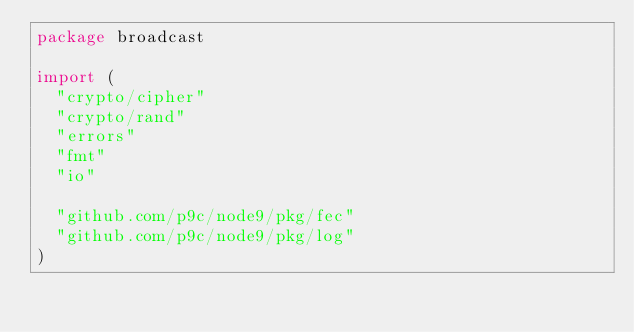<code> <loc_0><loc_0><loc_500><loc_500><_Go_>package broadcast

import (
	"crypto/cipher"
	"crypto/rand"
	"errors"
	"fmt"
	"io"

	"github.com/p9c/node9/pkg/fec"
	"github.com/p9c/node9/pkg/log"
)
</code> 